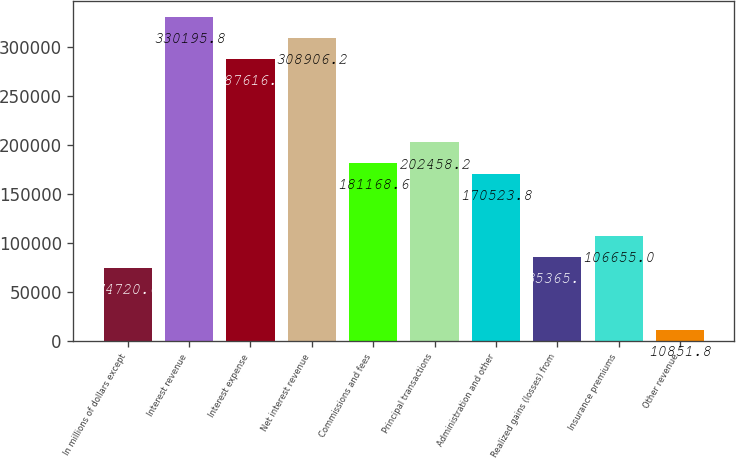<chart> <loc_0><loc_0><loc_500><loc_500><bar_chart><fcel>In millions of dollars except<fcel>Interest revenue<fcel>Interest expense<fcel>Net interest revenue<fcel>Commissions and fees<fcel>Principal transactions<fcel>Administration and other<fcel>Realized gains (losses) from<fcel>Insurance premiums<fcel>Other revenue<nl><fcel>74720.6<fcel>330196<fcel>287617<fcel>308906<fcel>181169<fcel>202458<fcel>170524<fcel>85365.4<fcel>106655<fcel>10851.8<nl></chart> 